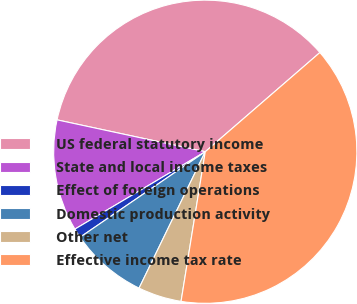<chart> <loc_0><loc_0><loc_500><loc_500><pie_chart><fcel>US federal statutory income<fcel>State and local income taxes<fcel>Effect of foreign operations<fcel>Domestic production activity<fcel>Other net<fcel>Effective income tax rate<nl><fcel>35.28%<fcel>11.9%<fcel>1.01%<fcel>8.27%<fcel>4.64%<fcel>38.91%<nl></chart> 